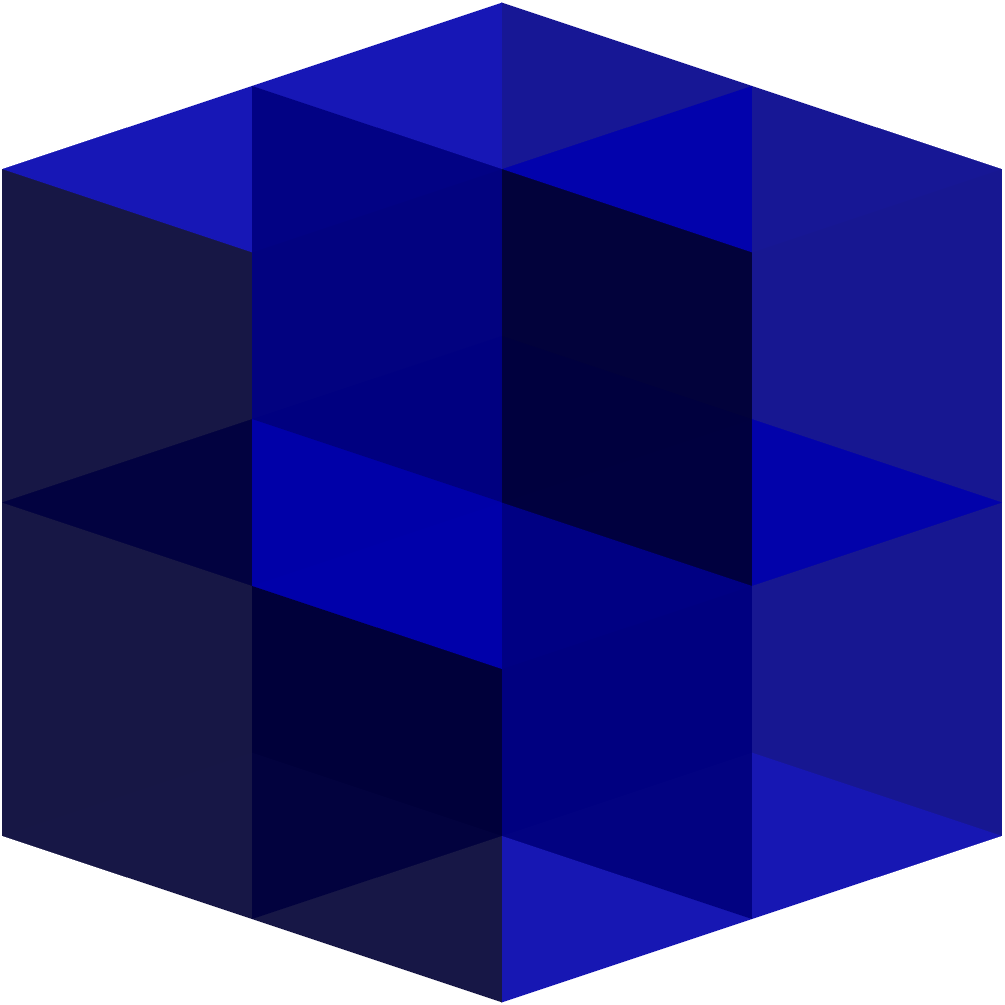Based on the 3D structure shown in the image, how many cubes are present in total? To determine the number of cubes in the 3D structure, let's analyze it layer by layer:

1. Bottom layer:
   - We can see a $2 \times 2$ square base, which consists of 4 cubes.

2. Top layer:
   - We can observe 3 cubes on top of the bottom layer.

3. Counting the cubes:
   - Bottom layer: 4 cubes
   - Top layer: 3 cubes
   - Total: $4 + 3 = 7$ cubes

4. Verification:
   - We can cross-check by counting the visible faces and corners of the structure.
   - The structure has a clear L-shape when viewed from above, confirming our count.

Therefore, the total number of cubes in the 3D structure is 7.
Answer: 7 cubes 